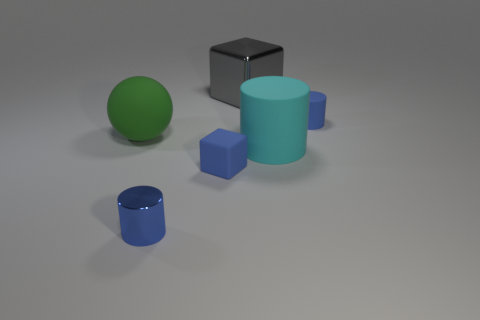Add 1 tiny green cylinders. How many objects exist? 7 Subtract all balls. How many objects are left? 5 Subtract all large green matte objects. Subtract all big green things. How many objects are left? 4 Add 6 matte objects. How many matte objects are left? 10 Add 3 small gray metal spheres. How many small gray metal spheres exist? 3 Subtract 0 brown cylinders. How many objects are left? 6 